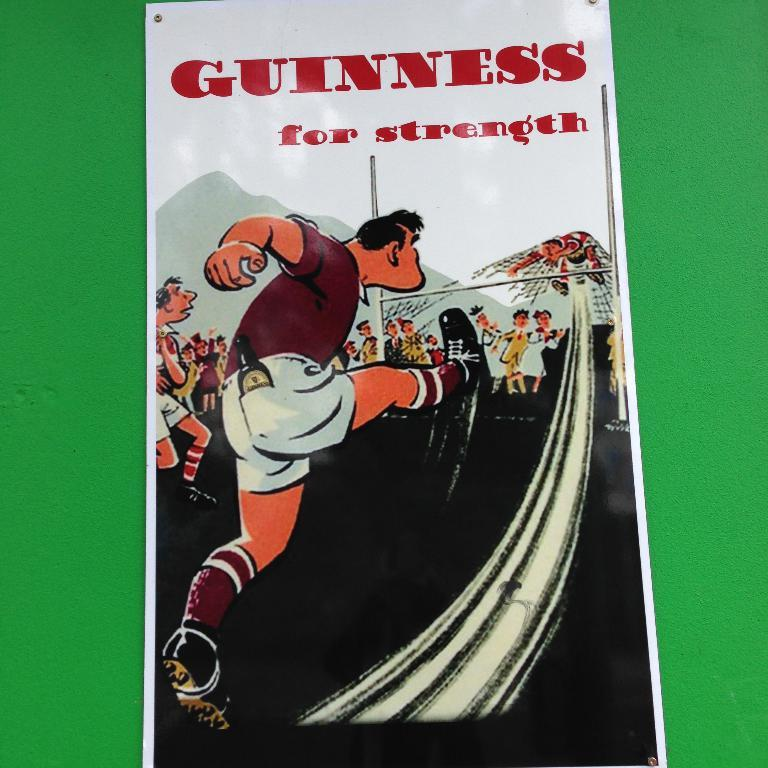<image>
Provide a brief description of the given image. A poster that says Guinness for strength with a kicker on it. 